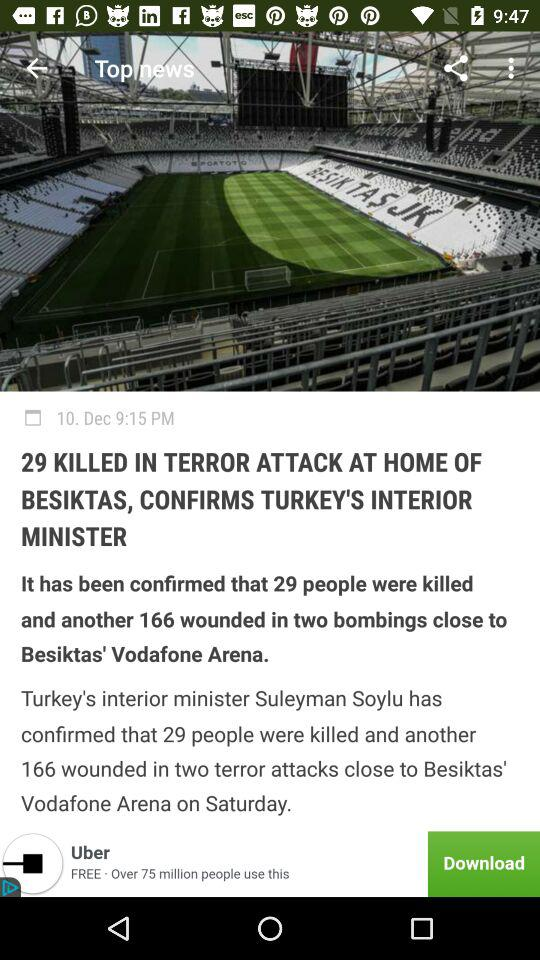What is the publication date? The publication date is December 10. 